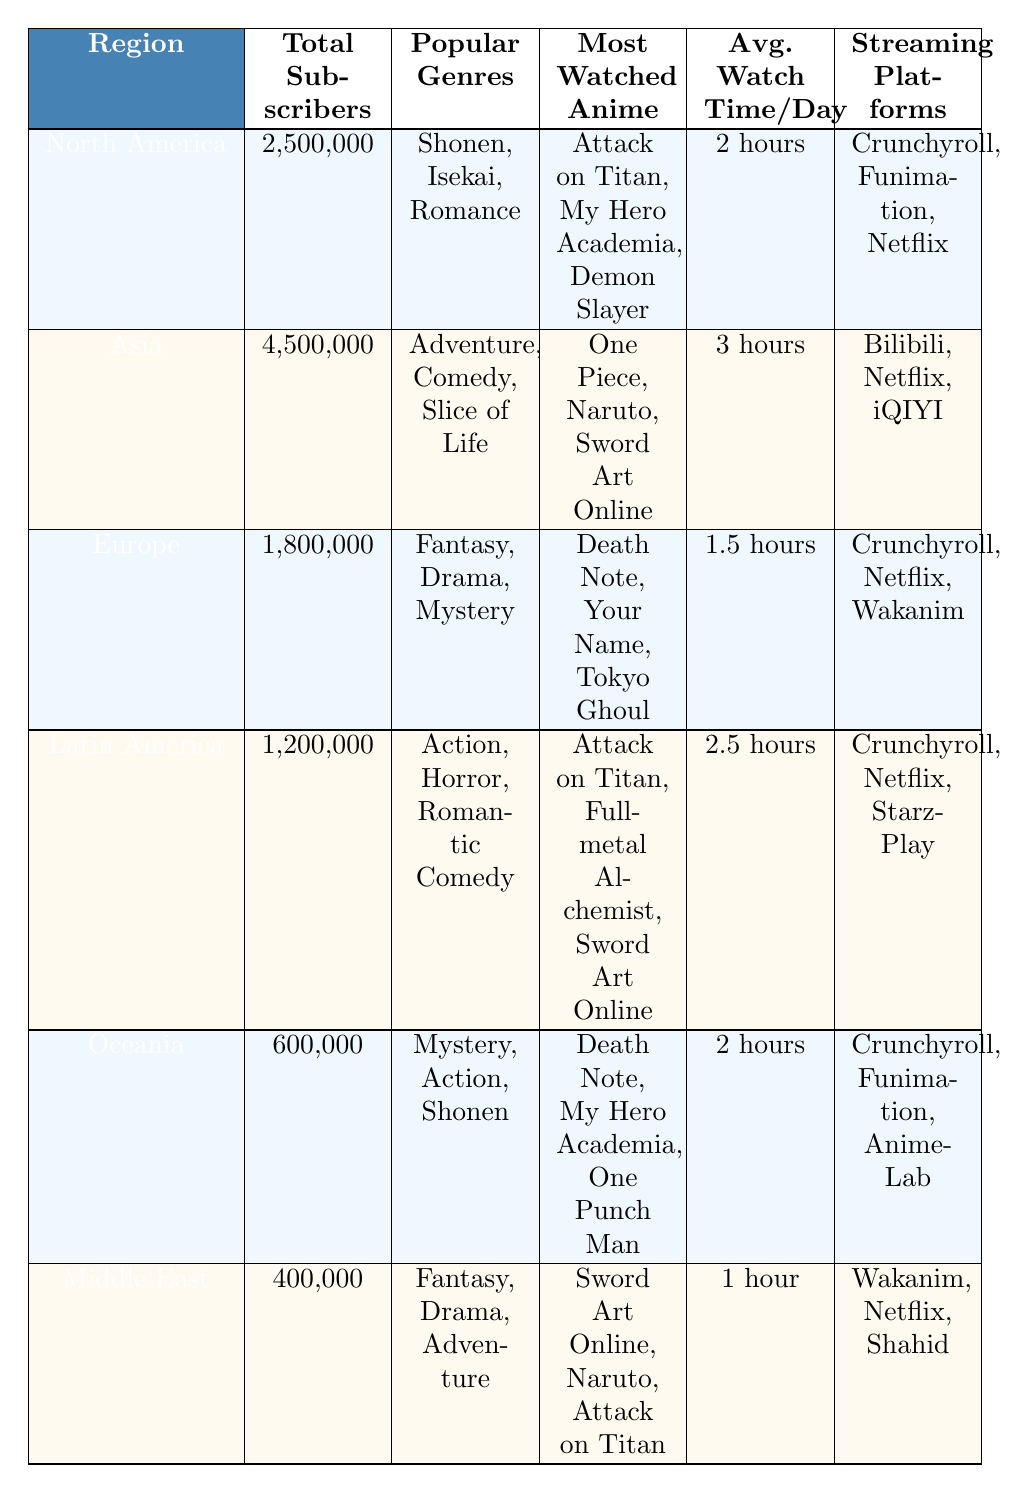What region has the highest number of subscribers? Referring to the table, Asia has the highest number of subscribers at 4,500,000.
Answer: Asia Which popular genre is shared by North America and Oceania? Both North America and Oceania list Shonen as one of their popular genres.
Answer: Shonen What is the average watch time per day for subscribers in Europe? According to the table, the average watch time per day for Europe is 1.5 hours.
Answer: 1.5 hours Is "Death Note" the most watched anime in Latin America? No, the most watched anime in Latin America includes "Attack on Titan," "Fullmetal Alchemist," and "Sword Art Online," but not "Death Note."
Answer: No Which region has the least number of subscribers and how many are there? The region with the least number of subscribers is the Middle East with 400,000 subscribers.
Answer: Middle East, 400,000 If we sum the total subscribers from North America and Latin America, what is the total? North America has 2,500,000 subscribers and Latin America has 1,200,000 subscribers, so the total is 2,500,000 + 1,200,000 = 3,700,000.
Answer: 3,700,000 Which region has the highest average watch time per day and what is it? Asia has the highest average watch time per day at 3 hours according to the data in the table.
Answer: 3 hours How many different streaming platforms are listed for the Middle East? The table indicates that the Middle East has three streaming platforms: Wakanim, Netflix, and Shahid.
Answer: 3 What genre is the most popular in Latin America? According to the table, the most popular genre in Latin America is Action.
Answer: Action Do any regions share the same most watched anime? Yes, "Attack on Titan" is listed as the most watched anime in both North America and Latin America.
Answer: Yes 